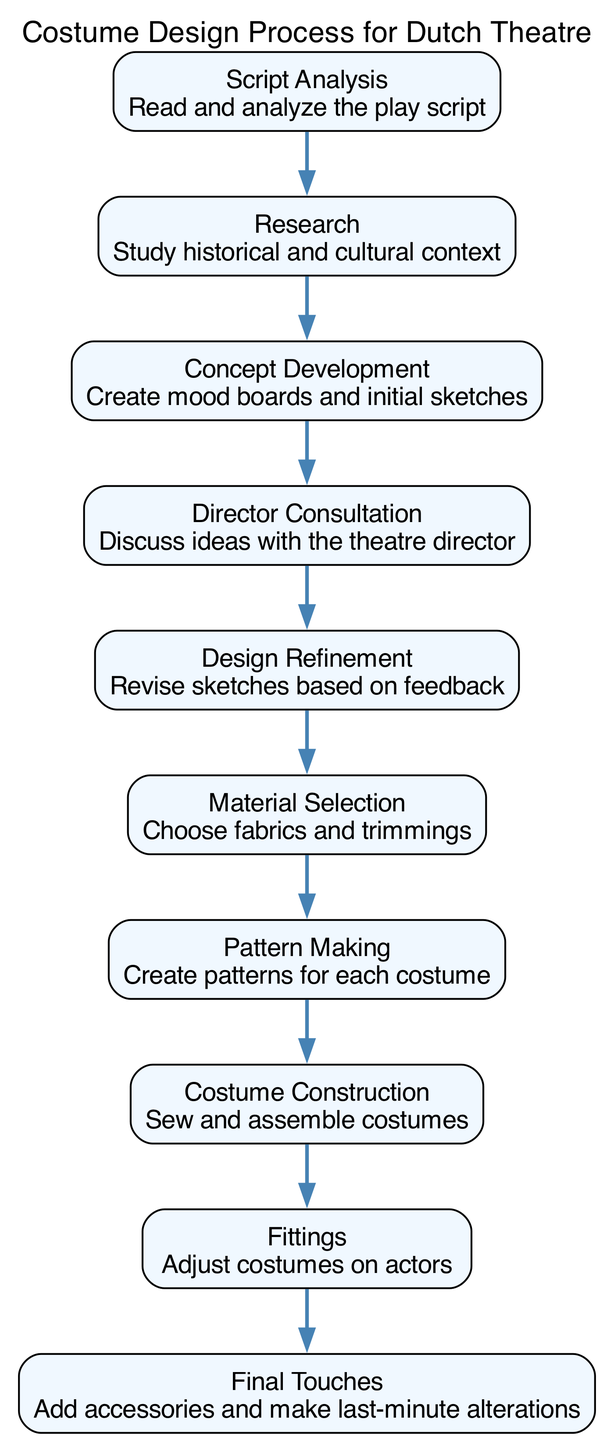What is the first step in the costume design process? The first step is indicated as "Script Analysis". This node is positioned at the top of the flow diagram, signifying it as the starting point of the process.
Answer: Script Analysis How many steps are there in the costume design process? By counting the number of nodes listed in the diagram, we can identify that there are 10 distinct steps in the costume design process.
Answer: 10 What follows "Concept Development" in the process? The arrow leading out from "Concept Development" directs to "Director Consultation". This shows the progression in the design process after the concept has been developed.
Answer: Director Consultation Which step is completed before "Fittings"? The connection shows that "Costume Construction" must be completed prior to the "Fittings" step, indicating an order in the process.
Answer: Costume Construction What is the main focus of the "Research" step? "Research" involves studying historical and cultural context, which is detailed in the parenthesis of the node associated with that step.
Answer: Study historical and cultural context How many connections are there between the steps? By examining the arrows that illustrate the flow from one step to the next, we can identify that there are 9 connections linking the steps together.
Answer: 9 Which step involves discussing ideas with the theatre director? The corresponding node indicates that "Director Consultation" is where ideas are discussed between the designer and the theatre director, clearly labeled in the diagram.
Answer: Director Consultation What do designers do during the "Design Refinement" step? The "Design Refinement" node specifies that this step involves revising sketches based on feedback received earlier in the process.
Answer: Revise sketches based on feedback Which step is directly after "Material Selection"? The arrow indicates that "Pattern Making" follows "Material Selection", showing the logical progression from choosing materials to creating patterns for costumes.
Answer: Pattern Making 